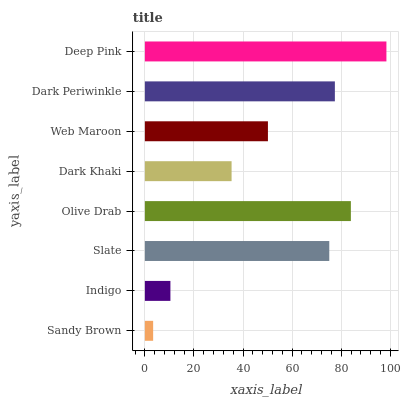Is Sandy Brown the minimum?
Answer yes or no. Yes. Is Deep Pink the maximum?
Answer yes or no. Yes. Is Indigo the minimum?
Answer yes or no. No. Is Indigo the maximum?
Answer yes or no. No. Is Indigo greater than Sandy Brown?
Answer yes or no. Yes. Is Sandy Brown less than Indigo?
Answer yes or no. Yes. Is Sandy Brown greater than Indigo?
Answer yes or no. No. Is Indigo less than Sandy Brown?
Answer yes or no. No. Is Slate the high median?
Answer yes or no. Yes. Is Web Maroon the low median?
Answer yes or no. Yes. Is Web Maroon the high median?
Answer yes or no. No. Is Indigo the low median?
Answer yes or no. No. 